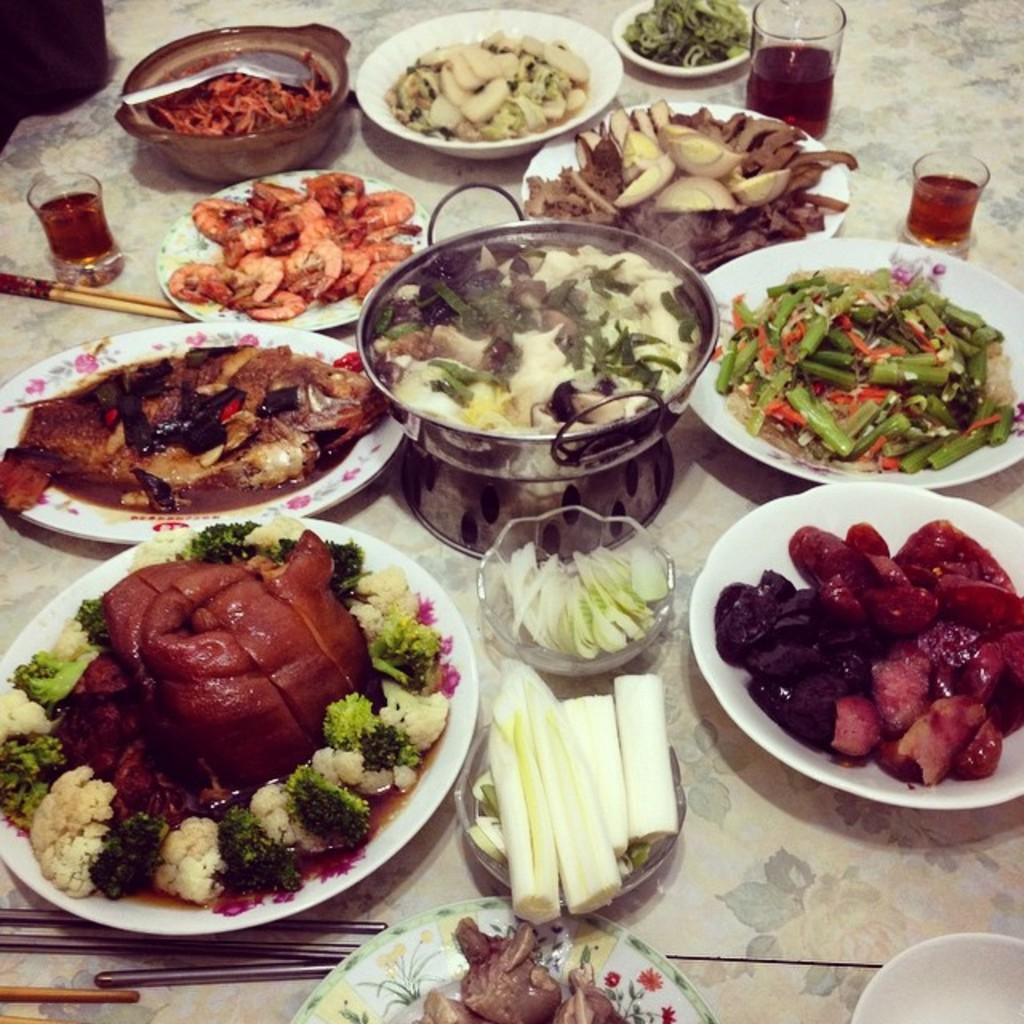Please provide a concise description of this image. On the table we can see the bowls, plates, meat, potatoes pieces, onion pieces, cabbages, wine glasses, spoon, chopsticks, meat and other food items. 